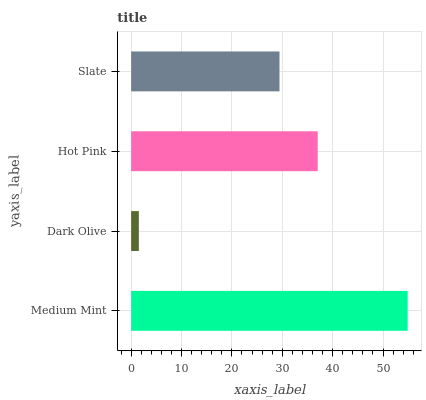Is Dark Olive the minimum?
Answer yes or no. Yes. Is Medium Mint the maximum?
Answer yes or no. Yes. Is Hot Pink the minimum?
Answer yes or no. No. Is Hot Pink the maximum?
Answer yes or no. No. Is Hot Pink greater than Dark Olive?
Answer yes or no. Yes. Is Dark Olive less than Hot Pink?
Answer yes or no. Yes. Is Dark Olive greater than Hot Pink?
Answer yes or no. No. Is Hot Pink less than Dark Olive?
Answer yes or no. No. Is Hot Pink the high median?
Answer yes or no. Yes. Is Slate the low median?
Answer yes or no. Yes. Is Slate the high median?
Answer yes or no. No. Is Dark Olive the low median?
Answer yes or no. No. 